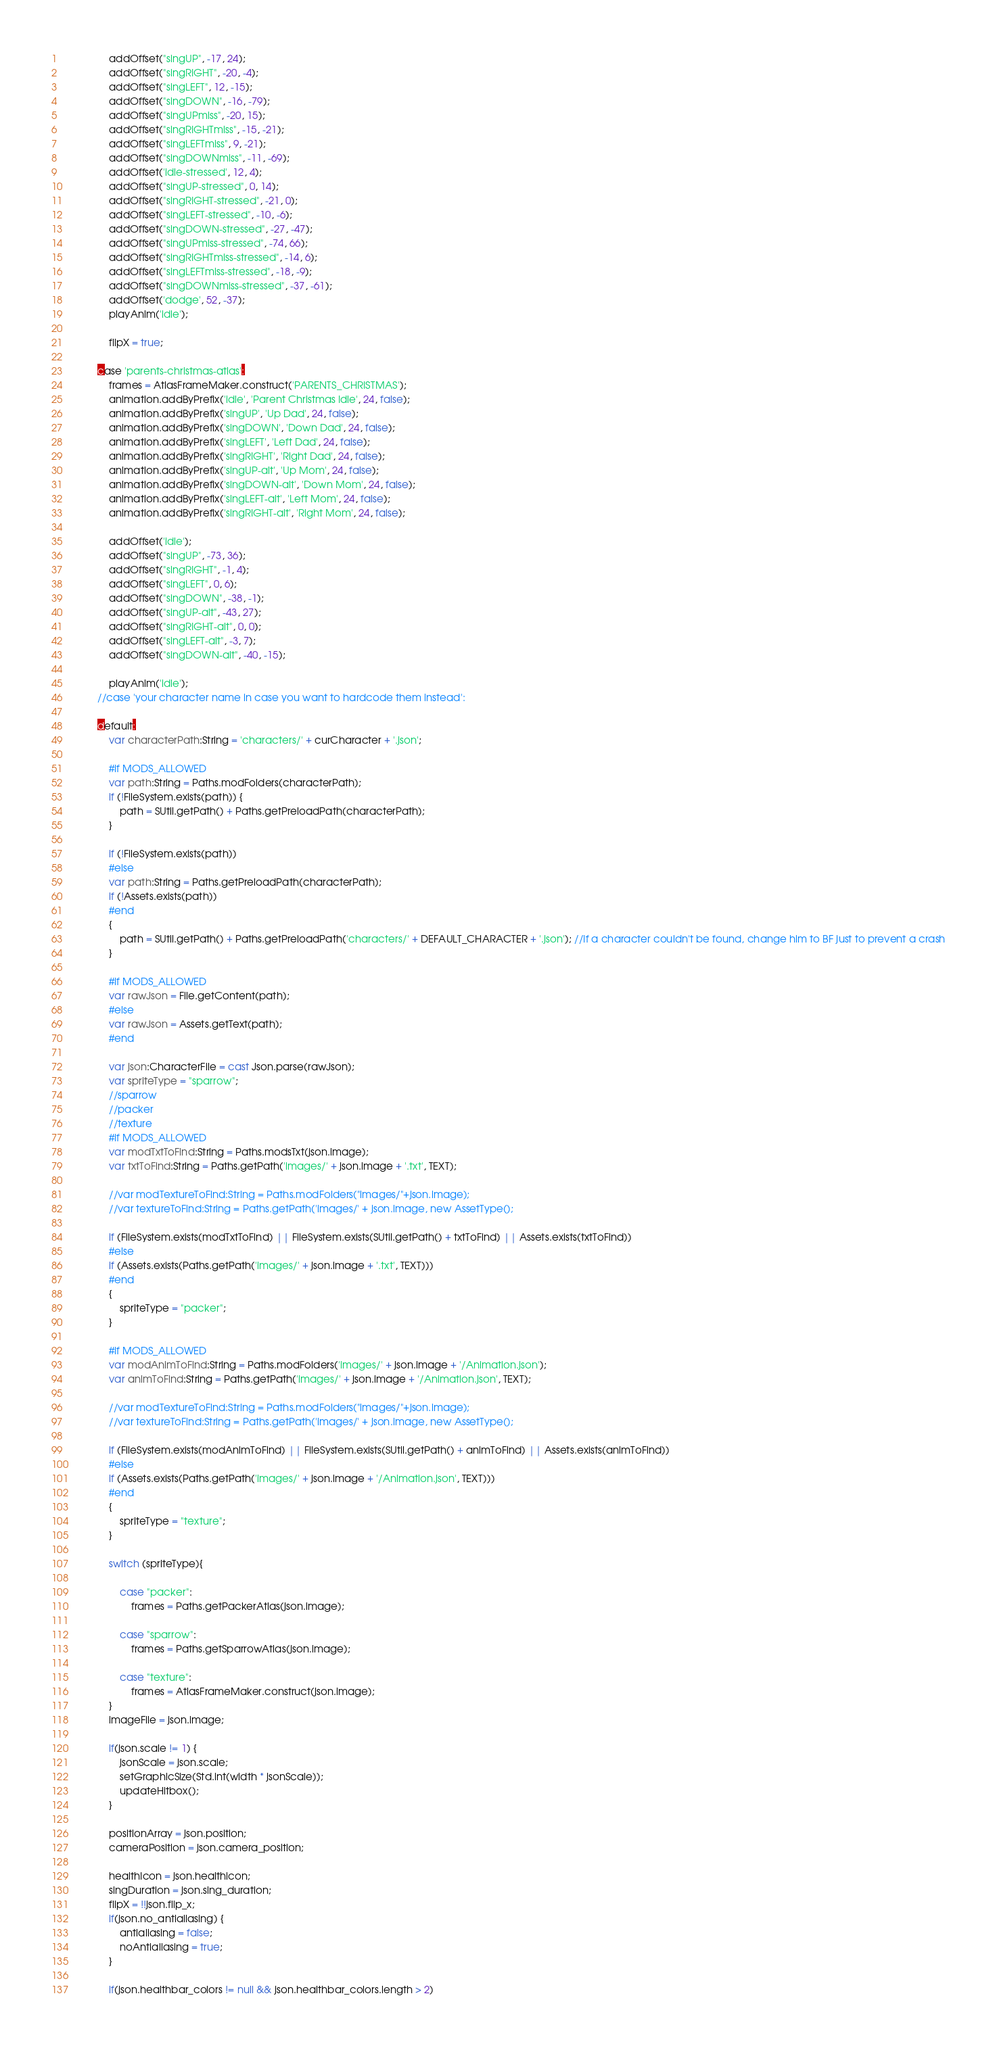<code> <loc_0><loc_0><loc_500><loc_500><_Haxe_>				addOffset("singUP", -17, 24);
				addOffset("singRIGHT", -20, -4);
				addOffset("singLEFT", 12, -15);
				addOffset("singDOWN", -16, -79);
				addOffset("singUPmiss", -20, 15);
				addOffset("singRIGHTmiss", -15, -21);
				addOffset("singLEFTmiss", 9, -21);
				addOffset("singDOWNmiss", -11, -69);
				addOffset('idle-stressed', 12, 4);
				addOffset("singUP-stressed", 0, 14);
				addOffset("singRIGHT-stressed", -21, 0);
				addOffset("singLEFT-stressed", -10, -6);
				addOffset("singDOWN-stressed", -27, -47);
				addOffset("singUPmiss-stressed", -74, 66);
				addOffset("singRIGHTmiss-stressed", -14, 6);
				addOffset("singLEFTmiss-stressed", -18, -9);
				addOffset("singDOWNmiss-stressed", -37, -61);
				addOffset('dodge', 52, -37);
				playAnim('idle');

				flipX = true;

			case 'parents-christmas-atlas':
				frames = AtlasFrameMaker.construct('PARENTS_CHRISTMAS');
				animation.addByPrefix('idle', 'Parent Christmas Idle', 24, false);
				animation.addByPrefix('singUP', 'Up Dad', 24, false);
				animation.addByPrefix('singDOWN', 'Down Dad', 24, false);
				animation.addByPrefix('singLEFT', 'Left Dad', 24, false);
				animation.addByPrefix('singRIGHT', 'Right Dad', 24, false);
				animation.addByPrefix('singUP-alt', 'Up Mom', 24, false);
				animation.addByPrefix('singDOWN-alt', 'Down Mom', 24, false);
				animation.addByPrefix('singLEFT-alt', 'Left Mom', 24, false);
				animation.addByPrefix('singRIGHT-alt', 'Right Mom', 24, false);

				addOffset('idle');
				addOffset("singUP", -73, 36);
				addOffset("singRIGHT", -1, 4);
				addOffset("singLEFT", 0, 6);
				addOffset("singDOWN", -38, -1);
				addOffset("singUP-alt", -43, 27);
				addOffset("singRIGHT-alt", 0, 0);
				addOffset("singLEFT-alt", -3, 7);
				addOffset("singDOWN-alt", -40, -15);

				playAnim('idle');
			//case 'your character name in case you want to hardcode them instead':

			default:
				var characterPath:String = 'characters/' + curCharacter + '.json';

				#if MODS_ALLOWED
				var path:String = Paths.modFolders(characterPath);
				if (!FileSystem.exists(path)) {
					path = SUtil.getPath() + Paths.getPreloadPath(characterPath);
				}

				if (!FileSystem.exists(path))
				#else
				var path:String = Paths.getPreloadPath(characterPath);
				if (!Assets.exists(path))
				#end
				{
					path = SUtil.getPath() + Paths.getPreloadPath('characters/' + DEFAULT_CHARACTER + '.json'); //If a character couldn't be found, change him to BF just to prevent a crash
				}

				#if MODS_ALLOWED
				var rawJson = File.getContent(path);
				#else
				var rawJson = Assets.getText(path);
				#end

				var json:CharacterFile = cast Json.parse(rawJson);
				var spriteType = "sparrow";
				//sparrow
				//packer
				//texture
				#if MODS_ALLOWED
				var modTxtToFind:String = Paths.modsTxt(json.image);
				var txtToFind:String = Paths.getPath('images/' + json.image + '.txt', TEXT);
				
				//var modTextureToFind:String = Paths.modFolders("images/"+json.image);
				//var textureToFind:String = Paths.getPath('images/' + json.image, new AssetType();
				
				if (FileSystem.exists(modTxtToFind) || FileSystem.exists(SUtil.getPath() + txtToFind) || Assets.exists(txtToFind))
				#else
				if (Assets.exists(Paths.getPath('images/' + json.image + '.txt', TEXT)))
				#end
				{
					spriteType = "packer";
				}
				
				#if MODS_ALLOWED
				var modAnimToFind:String = Paths.modFolders('images/' + json.image + '/Animation.json');
				var animToFind:String = Paths.getPath('images/' + json.image + '/Animation.json', TEXT);
				
				//var modTextureToFind:String = Paths.modFolders("images/"+json.image);
				//var textureToFind:String = Paths.getPath('images/' + json.image, new AssetType();
				
				if (FileSystem.exists(modAnimToFind) || FileSystem.exists(SUtil.getPath() + animToFind) || Assets.exists(animToFind))
				#else
				if (Assets.exists(Paths.getPath('images/' + json.image + '/Animation.json', TEXT)))
				#end
				{
					spriteType = "texture";
				}

				switch (spriteType){
					
					case "packer":
						frames = Paths.getPackerAtlas(json.image);
					
					case "sparrow":
						frames = Paths.getSparrowAtlas(json.image);
					
					case "texture":
						frames = AtlasFrameMaker.construct(json.image);
				}
				imageFile = json.image;

				if(json.scale != 1) {
					jsonScale = json.scale;
					setGraphicSize(Std.int(width * jsonScale));
					updateHitbox();
				}

				positionArray = json.position;
				cameraPosition = json.camera_position;

				healthIcon = json.healthicon;
				singDuration = json.sing_duration;
				flipX = !!json.flip_x;
				if(json.no_antialiasing) {
					antialiasing = false;
					noAntialiasing = true;
				}

				if(json.healthbar_colors != null && json.healthbar_colors.length > 2)</code> 